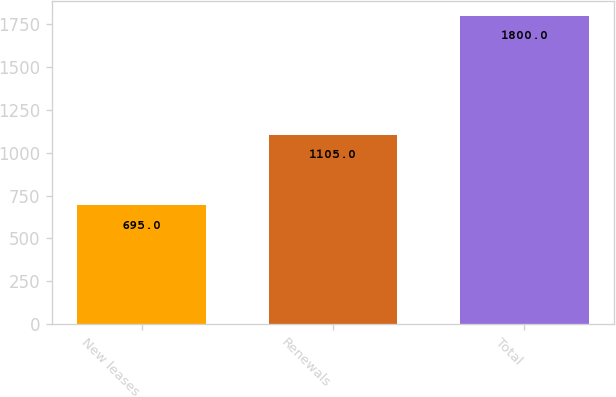Convert chart. <chart><loc_0><loc_0><loc_500><loc_500><bar_chart><fcel>New leases<fcel>Renewals<fcel>Total<nl><fcel>695<fcel>1105<fcel>1800<nl></chart> 